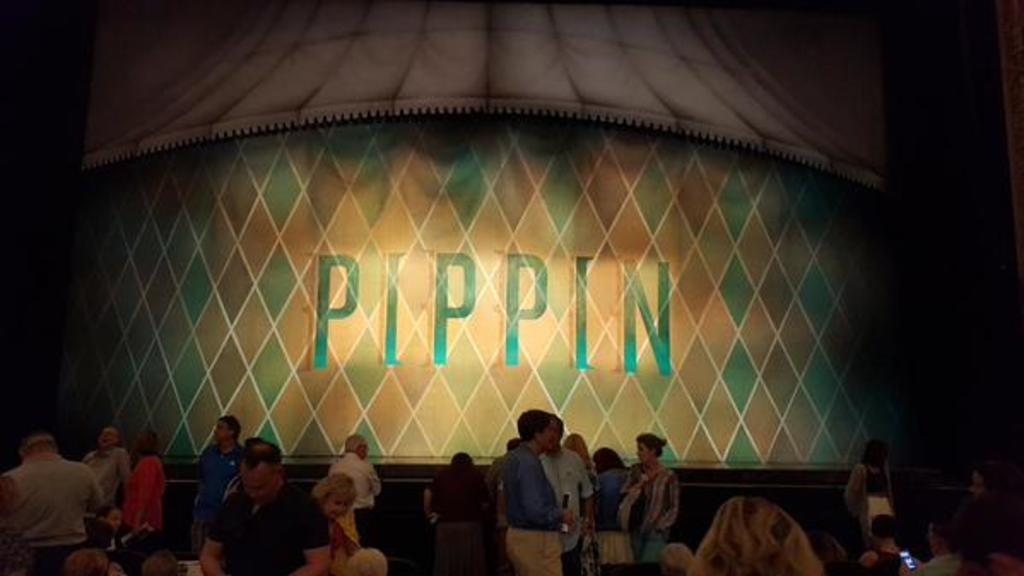What are the people in the image doing? There are people standing and sitting in the image. Where are the standing people located? The standing people are on the floor. What are the sitting people using for support? The sitting people are on chairs. What type of veil can be seen on the swing in the image? There is no swing or veil present in the image. What kind of jewel is being worn by the people in the image? There is no information about any jewelry being worn by the people in the image. 